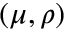<formula> <loc_0><loc_0><loc_500><loc_500>( \mu , \rho )</formula> 